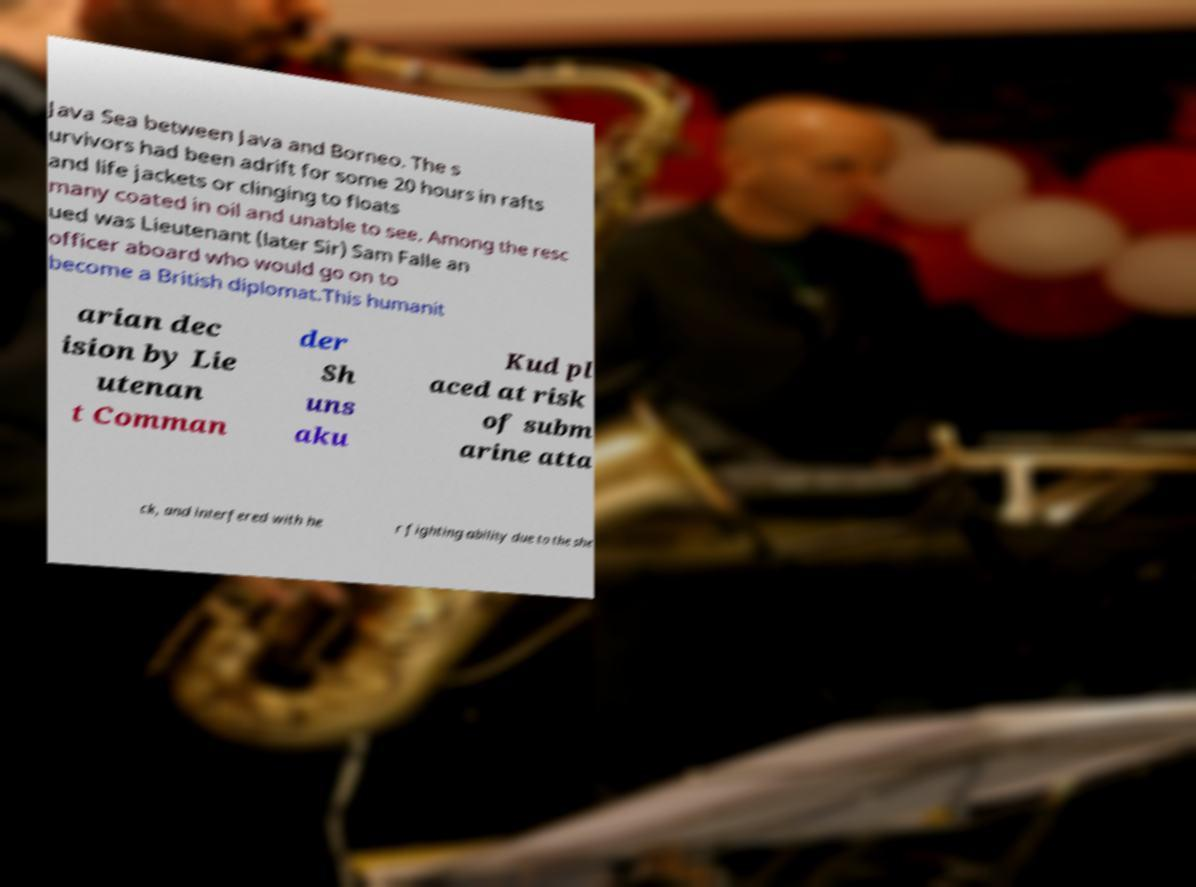Can you accurately transcribe the text from the provided image for me? Java Sea between Java and Borneo. The s urvivors had been adrift for some 20 hours in rafts and life jackets or clinging to floats many coated in oil and unable to see. Among the resc ued was Lieutenant (later Sir) Sam Falle an officer aboard who would go on to become a British diplomat.This humanit arian dec ision by Lie utenan t Comman der Sh uns aku Kud pl aced at risk of subm arine atta ck, and interfered with he r fighting ability due to the she 